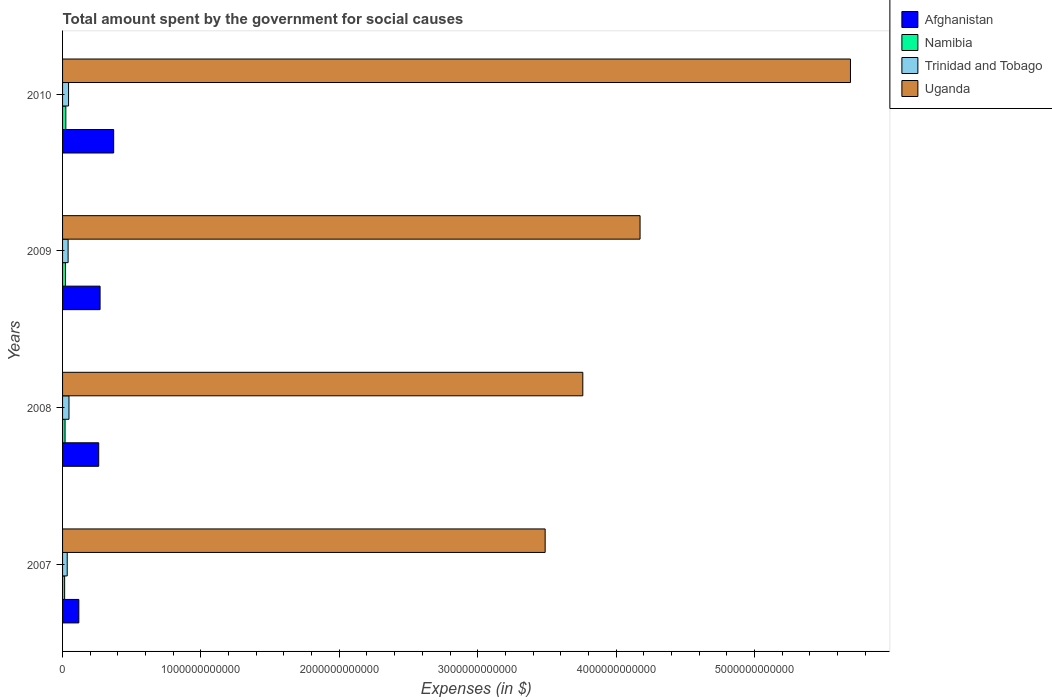Are the number of bars per tick equal to the number of legend labels?
Offer a very short reply. Yes. Are the number of bars on each tick of the Y-axis equal?
Your answer should be very brief. Yes. How many bars are there on the 4th tick from the bottom?
Offer a very short reply. 4. What is the label of the 4th group of bars from the top?
Your answer should be very brief. 2007. What is the amount spent for social causes by the government in Afghanistan in 2007?
Your answer should be compact. 1.18e+11. Across all years, what is the maximum amount spent for social causes by the government in Uganda?
Offer a terse response. 5.69e+12. Across all years, what is the minimum amount spent for social causes by the government in Uganda?
Ensure brevity in your answer.  3.49e+12. In which year was the amount spent for social causes by the government in Trinidad and Tobago maximum?
Keep it short and to the point. 2008. In which year was the amount spent for social causes by the government in Uganda minimum?
Offer a terse response. 2007. What is the total amount spent for social causes by the government in Uganda in the graph?
Offer a very short reply. 1.71e+13. What is the difference between the amount spent for social causes by the government in Trinidad and Tobago in 2008 and that in 2010?
Offer a terse response. 2.97e+09. What is the difference between the amount spent for social causes by the government in Trinidad and Tobago in 2009 and the amount spent for social causes by the government in Afghanistan in 2007?
Provide a succinct answer. -7.76e+1. What is the average amount spent for social causes by the government in Trinidad and Tobago per year?
Provide a succinct answer. 4.08e+1. In the year 2010, what is the difference between the amount spent for social causes by the government in Namibia and amount spent for social causes by the government in Trinidad and Tobago?
Offer a terse response. -1.98e+1. In how many years, is the amount spent for social causes by the government in Trinidad and Tobago greater than 2400000000000 $?
Your answer should be very brief. 0. What is the ratio of the amount spent for social causes by the government in Namibia in 2007 to that in 2008?
Your answer should be very brief. 0.83. Is the difference between the amount spent for social causes by the government in Namibia in 2007 and 2008 greater than the difference between the amount spent for social causes by the government in Trinidad and Tobago in 2007 and 2008?
Make the answer very short. Yes. What is the difference between the highest and the second highest amount spent for social causes by the government in Namibia?
Offer a terse response. 2.68e+09. What is the difference between the highest and the lowest amount spent for social causes by the government in Trinidad and Tobago?
Your answer should be very brief. 1.28e+1. Is it the case that in every year, the sum of the amount spent for social causes by the government in Trinidad and Tobago and amount spent for social causes by the government in Namibia is greater than the sum of amount spent for social causes by the government in Afghanistan and amount spent for social causes by the government in Uganda?
Offer a very short reply. No. What does the 4th bar from the top in 2008 represents?
Your answer should be very brief. Afghanistan. What does the 1st bar from the bottom in 2008 represents?
Make the answer very short. Afghanistan. Is it the case that in every year, the sum of the amount spent for social causes by the government in Trinidad and Tobago and amount spent for social causes by the government in Namibia is greater than the amount spent for social causes by the government in Afghanistan?
Provide a short and direct response. No. How many bars are there?
Offer a terse response. 16. How many years are there in the graph?
Make the answer very short. 4. What is the difference between two consecutive major ticks on the X-axis?
Offer a terse response. 1.00e+12. Are the values on the major ticks of X-axis written in scientific E-notation?
Your answer should be very brief. No. Does the graph contain grids?
Your answer should be very brief. No. What is the title of the graph?
Your response must be concise. Total amount spent by the government for social causes. What is the label or title of the X-axis?
Offer a terse response. Expenses (in $). What is the Expenses (in $) of Afghanistan in 2007?
Provide a succinct answer. 1.18e+11. What is the Expenses (in $) in Namibia in 2007?
Give a very brief answer. 1.49e+1. What is the Expenses (in $) in Trinidad and Tobago in 2007?
Your answer should be compact. 3.36e+1. What is the Expenses (in $) of Uganda in 2007?
Your answer should be very brief. 3.49e+12. What is the Expenses (in $) of Afghanistan in 2008?
Ensure brevity in your answer.  2.61e+11. What is the Expenses (in $) in Namibia in 2008?
Offer a very short reply. 1.80e+1. What is the Expenses (in $) of Trinidad and Tobago in 2008?
Your response must be concise. 4.63e+1. What is the Expenses (in $) in Uganda in 2008?
Offer a very short reply. 3.76e+12. What is the Expenses (in $) in Afghanistan in 2009?
Your response must be concise. 2.71e+11. What is the Expenses (in $) of Namibia in 2009?
Provide a succinct answer. 2.09e+1. What is the Expenses (in $) in Trinidad and Tobago in 2009?
Provide a short and direct response. 4.00e+1. What is the Expenses (in $) of Uganda in 2009?
Make the answer very short. 4.17e+12. What is the Expenses (in $) in Afghanistan in 2010?
Offer a terse response. 3.69e+11. What is the Expenses (in $) of Namibia in 2010?
Your response must be concise. 2.36e+1. What is the Expenses (in $) of Trinidad and Tobago in 2010?
Provide a short and direct response. 4.34e+1. What is the Expenses (in $) in Uganda in 2010?
Make the answer very short. 5.69e+12. Across all years, what is the maximum Expenses (in $) of Afghanistan?
Your answer should be very brief. 3.69e+11. Across all years, what is the maximum Expenses (in $) in Namibia?
Make the answer very short. 2.36e+1. Across all years, what is the maximum Expenses (in $) of Trinidad and Tobago?
Keep it short and to the point. 4.63e+1. Across all years, what is the maximum Expenses (in $) in Uganda?
Make the answer very short. 5.69e+12. Across all years, what is the minimum Expenses (in $) of Afghanistan?
Make the answer very short. 1.18e+11. Across all years, what is the minimum Expenses (in $) in Namibia?
Give a very brief answer. 1.49e+1. Across all years, what is the minimum Expenses (in $) in Trinidad and Tobago?
Offer a very short reply. 3.36e+1. Across all years, what is the minimum Expenses (in $) in Uganda?
Keep it short and to the point. 3.49e+12. What is the total Expenses (in $) in Afghanistan in the graph?
Provide a succinct answer. 1.02e+12. What is the total Expenses (in $) in Namibia in the graph?
Your response must be concise. 7.75e+1. What is the total Expenses (in $) in Trinidad and Tobago in the graph?
Your response must be concise. 1.63e+11. What is the total Expenses (in $) in Uganda in the graph?
Your answer should be compact. 1.71e+13. What is the difference between the Expenses (in $) of Afghanistan in 2007 and that in 2008?
Your answer should be compact. -1.44e+11. What is the difference between the Expenses (in $) of Namibia in 2007 and that in 2008?
Your answer should be compact. -3.08e+09. What is the difference between the Expenses (in $) of Trinidad and Tobago in 2007 and that in 2008?
Your answer should be very brief. -1.28e+1. What is the difference between the Expenses (in $) of Uganda in 2007 and that in 2008?
Your answer should be compact. -2.72e+11. What is the difference between the Expenses (in $) of Afghanistan in 2007 and that in 2009?
Ensure brevity in your answer.  -1.53e+11. What is the difference between the Expenses (in $) in Namibia in 2007 and that in 2009?
Offer a terse response. -5.99e+09. What is the difference between the Expenses (in $) of Trinidad and Tobago in 2007 and that in 2009?
Your answer should be very brief. -6.47e+09. What is the difference between the Expenses (in $) in Uganda in 2007 and that in 2009?
Provide a short and direct response. -6.86e+11. What is the difference between the Expenses (in $) in Afghanistan in 2007 and that in 2010?
Make the answer very short. -2.52e+11. What is the difference between the Expenses (in $) of Namibia in 2007 and that in 2010?
Your answer should be compact. -8.67e+09. What is the difference between the Expenses (in $) in Trinidad and Tobago in 2007 and that in 2010?
Keep it short and to the point. -9.80e+09. What is the difference between the Expenses (in $) of Uganda in 2007 and that in 2010?
Provide a short and direct response. -2.21e+12. What is the difference between the Expenses (in $) in Afghanistan in 2008 and that in 2009?
Your answer should be compact. -9.86e+09. What is the difference between the Expenses (in $) of Namibia in 2008 and that in 2009?
Ensure brevity in your answer.  -2.91e+09. What is the difference between the Expenses (in $) of Trinidad and Tobago in 2008 and that in 2009?
Your answer should be compact. 6.29e+09. What is the difference between the Expenses (in $) of Uganda in 2008 and that in 2009?
Ensure brevity in your answer.  -4.14e+11. What is the difference between the Expenses (in $) of Afghanistan in 2008 and that in 2010?
Offer a terse response. -1.08e+11. What is the difference between the Expenses (in $) in Namibia in 2008 and that in 2010?
Provide a succinct answer. -5.59e+09. What is the difference between the Expenses (in $) in Trinidad and Tobago in 2008 and that in 2010?
Ensure brevity in your answer.  2.97e+09. What is the difference between the Expenses (in $) of Uganda in 2008 and that in 2010?
Provide a succinct answer. -1.93e+12. What is the difference between the Expenses (in $) of Afghanistan in 2009 and that in 2010?
Make the answer very short. -9.83e+1. What is the difference between the Expenses (in $) in Namibia in 2009 and that in 2010?
Offer a very short reply. -2.68e+09. What is the difference between the Expenses (in $) of Trinidad and Tobago in 2009 and that in 2010?
Ensure brevity in your answer.  -3.33e+09. What is the difference between the Expenses (in $) in Uganda in 2009 and that in 2010?
Offer a very short reply. -1.52e+12. What is the difference between the Expenses (in $) of Afghanistan in 2007 and the Expenses (in $) of Namibia in 2008?
Your answer should be very brief. 9.97e+1. What is the difference between the Expenses (in $) of Afghanistan in 2007 and the Expenses (in $) of Trinidad and Tobago in 2008?
Give a very brief answer. 7.13e+1. What is the difference between the Expenses (in $) in Afghanistan in 2007 and the Expenses (in $) in Uganda in 2008?
Offer a very short reply. -3.64e+12. What is the difference between the Expenses (in $) of Namibia in 2007 and the Expenses (in $) of Trinidad and Tobago in 2008?
Offer a very short reply. -3.14e+1. What is the difference between the Expenses (in $) of Namibia in 2007 and the Expenses (in $) of Uganda in 2008?
Keep it short and to the point. -3.74e+12. What is the difference between the Expenses (in $) of Trinidad and Tobago in 2007 and the Expenses (in $) of Uganda in 2008?
Your answer should be very brief. -3.73e+12. What is the difference between the Expenses (in $) of Afghanistan in 2007 and the Expenses (in $) of Namibia in 2009?
Your response must be concise. 9.68e+1. What is the difference between the Expenses (in $) in Afghanistan in 2007 and the Expenses (in $) in Trinidad and Tobago in 2009?
Ensure brevity in your answer.  7.76e+1. What is the difference between the Expenses (in $) in Afghanistan in 2007 and the Expenses (in $) in Uganda in 2009?
Your answer should be very brief. -4.06e+12. What is the difference between the Expenses (in $) in Namibia in 2007 and the Expenses (in $) in Trinidad and Tobago in 2009?
Make the answer very short. -2.51e+1. What is the difference between the Expenses (in $) of Namibia in 2007 and the Expenses (in $) of Uganda in 2009?
Your response must be concise. -4.16e+12. What is the difference between the Expenses (in $) of Trinidad and Tobago in 2007 and the Expenses (in $) of Uganda in 2009?
Make the answer very short. -4.14e+12. What is the difference between the Expenses (in $) of Afghanistan in 2007 and the Expenses (in $) of Namibia in 2010?
Offer a very short reply. 9.41e+1. What is the difference between the Expenses (in $) in Afghanistan in 2007 and the Expenses (in $) in Trinidad and Tobago in 2010?
Offer a terse response. 7.43e+1. What is the difference between the Expenses (in $) of Afghanistan in 2007 and the Expenses (in $) of Uganda in 2010?
Offer a very short reply. -5.58e+12. What is the difference between the Expenses (in $) of Namibia in 2007 and the Expenses (in $) of Trinidad and Tobago in 2010?
Your answer should be compact. -2.84e+1. What is the difference between the Expenses (in $) in Namibia in 2007 and the Expenses (in $) in Uganda in 2010?
Keep it short and to the point. -5.68e+12. What is the difference between the Expenses (in $) in Trinidad and Tobago in 2007 and the Expenses (in $) in Uganda in 2010?
Offer a terse response. -5.66e+12. What is the difference between the Expenses (in $) in Afghanistan in 2008 and the Expenses (in $) in Namibia in 2009?
Your answer should be very brief. 2.40e+11. What is the difference between the Expenses (in $) in Afghanistan in 2008 and the Expenses (in $) in Trinidad and Tobago in 2009?
Your response must be concise. 2.21e+11. What is the difference between the Expenses (in $) in Afghanistan in 2008 and the Expenses (in $) in Uganda in 2009?
Give a very brief answer. -3.91e+12. What is the difference between the Expenses (in $) in Namibia in 2008 and the Expenses (in $) in Trinidad and Tobago in 2009?
Make the answer very short. -2.20e+1. What is the difference between the Expenses (in $) of Namibia in 2008 and the Expenses (in $) of Uganda in 2009?
Offer a terse response. -4.16e+12. What is the difference between the Expenses (in $) of Trinidad and Tobago in 2008 and the Expenses (in $) of Uganda in 2009?
Provide a short and direct response. -4.13e+12. What is the difference between the Expenses (in $) in Afghanistan in 2008 and the Expenses (in $) in Namibia in 2010?
Offer a very short reply. 2.38e+11. What is the difference between the Expenses (in $) in Afghanistan in 2008 and the Expenses (in $) in Trinidad and Tobago in 2010?
Offer a terse response. 2.18e+11. What is the difference between the Expenses (in $) of Afghanistan in 2008 and the Expenses (in $) of Uganda in 2010?
Your response must be concise. -5.43e+12. What is the difference between the Expenses (in $) of Namibia in 2008 and the Expenses (in $) of Trinidad and Tobago in 2010?
Provide a succinct answer. -2.53e+1. What is the difference between the Expenses (in $) in Namibia in 2008 and the Expenses (in $) in Uganda in 2010?
Provide a short and direct response. -5.68e+12. What is the difference between the Expenses (in $) of Trinidad and Tobago in 2008 and the Expenses (in $) of Uganda in 2010?
Provide a short and direct response. -5.65e+12. What is the difference between the Expenses (in $) in Afghanistan in 2009 and the Expenses (in $) in Namibia in 2010?
Ensure brevity in your answer.  2.47e+11. What is the difference between the Expenses (in $) in Afghanistan in 2009 and the Expenses (in $) in Trinidad and Tobago in 2010?
Provide a short and direct response. 2.28e+11. What is the difference between the Expenses (in $) in Afghanistan in 2009 and the Expenses (in $) in Uganda in 2010?
Offer a terse response. -5.42e+12. What is the difference between the Expenses (in $) of Namibia in 2009 and the Expenses (in $) of Trinidad and Tobago in 2010?
Offer a terse response. -2.24e+1. What is the difference between the Expenses (in $) in Namibia in 2009 and the Expenses (in $) in Uganda in 2010?
Provide a succinct answer. -5.67e+12. What is the difference between the Expenses (in $) of Trinidad and Tobago in 2009 and the Expenses (in $) of Uganda in 2010?
Provide a short and direct response. -5.65e+12. What is the average Expenses (in $) of Afghanistan per year?
Make the answer very short. 2.55e+11. What is the average Expenses (in $) of Namibia per year?
Make the answer very short. 1.94e+1. What is the average Expenses (in $) in Trinidad and Tobago per year?
Your response must be concise. 4.08e+1. What is the average Expenses (in $) in Uganda per year?
Provide a succinct answer. 4.28e+12. In the year 2007, what is the difference between the Expenses (in $) in Afghanistan and Expenses (in $) in Namibia?
Keep it short and to the point. 1.03e+11. In the year 2007, what is the difference between the Expenses (in $) in Afghanistan and Expenses (in $) in Trinidad and Tobago?
Your response must be concise. 8.41e+1. In the year 2007, what is the difference between the Expenses (in $) of Afghanistan and Expenses (in $) of Uganda?
Keep it short and to the point. -3.37e+12. In the year 2007, what is the difference between the Expenses (in $) of Namibia and Expenses (in $) of Trinidad and Tobago?
Give a very brief answer. -1.86e+1. In the year 2007, what is the difference between the Expenses (in $) of Namibia and Expenses (in $) of Uganda?
Your answer should be very brief. -3.47e+12. In the year 2007, what is the difference between the Expenses (in $) in Trinidad and Tobago and Expenses (in $) in Uganda?
Provide a short and direct response. -3.45e+12. In the year 2008, what is the difference between the Expenses (in $) of Afghanistan and Expenses (in $) of Namibia?
Offer a terse response. 2.43e+11. In the year 2008, what is the difference between the Expenses (in $) of Afghanistan and Expenses (in $) of Trinidad and Tobago?
Offer a very short reply. 2.15e+11. In the year 2008, what is the difference between the Expenses (in $) of Afghanistan and Expenses (in $) of Uganda?
Provide a succinct answer. -3.50e+12. In the year 2008, what is the difference between the Expenses (in $) of Namibia and Expenses (in $) of Trinidad and Tobago?
Offer a very short reply. -2.83e+1. In the year 2008, what is the difference between the Expenses (in $) in Namibia and Expenses (in $) in Uganda?
Your answer should be compact. -3.74e+12. In the year 2008, what is the difference between the Expenses (in $) of Trinidad and Tobago and Expenses (in $) of Uganda?
Give a very brief answer. -3.71e+12. In the year 2009, what is the difference between the Expenses (in $) in Afghanistan and Expenses (in $) in Namibia?
Your answer should be compact. 2.50e+11. In the year 2009, what is the difference between the Expenses (in $) in Afghanistan and Expenses (in $) in Trinidad and Tobago?
Provide a succinct answer. 2.31e+11. In the year 2009, what is the difference between the Expenses (in $) in Afghanistan and Expenses (in $) in Uganda?
Your answer should be very brief. -3.90e+12. In the year 2009, what is the difference between the Expenses (in $) of Namibia and Expenses (in $) of Trinidad and Tobago?
Keep it short and to the point. -1.91e+1. In the year 2009, what is the difference between the Expenses (in $) of Namibia and Expenses (in $) of Uganda?
Offer a very short reply. -4.15e+12. In the year 2009, what is the difference between the Expenses (in $) in Trinidad and Tobago and Expenses (in $) in Uganda?
Give a very brief answer. -4.13e+12. In the year 2010, what is the difference between the Expenses (in $) in Afghanistan and Expenses (in $) in Namibia?
Keep it short and to the point. 3.46e+11. In the year 2010, what is the difference between the Expenses (in $) of Afghanistan and Expenses (in $) of Trinidad and Tobago?
Keep it short and to the point. 3.26e+11. In the year 2010, what is the difference between the Expenses (in $) of Afghanistan and Expenses (in $) of Uganda?
Make the answer very short. -5.32e+12. In the year 2010, what is the difference between the Expenses (in $) of Namibia and Expenses (in $) of Trinidad and Tobago?
Your response must be concise. -1.98e+1. In the year 2010, what is the difference between the Expenses (in $) in Namibia and Expenses (in $) in Uganda?
Give a very brief answer. -5.67e+12. In the year 2010, what is the difference between the Expenses (in $) of Trinidad and Tobago and Expenses (in $) of Uganda?
Your response must be concise. -5.65e+12. What is the ratio of the Expenses (in $) of Afghanistan in 2007 to that in 2008?
Offer a very short reply. 0.45. What is the ratio of the Expenses (in $) of Namibia in 2007 to that in 2008?
Offer a very short reply. 0.83. What is the ratio of the Expenses (in $) of Trinidad and Tobago in 2007 to that in 2008?
Give a very brief answer. 0.72. What is the ratio of the Expenses (in $) of Uganda in 2007 to that in 2008?
Keep it short and to the point. 0.93. What is the ratio of the Expenses (in $) of Afghanistan in 2007 to that in 2009?
Give a very brief answer. 0.43. What is the ratio of the Expenses (in $) of Namibia in 2007 to that in 2009?
Ensure brevity in your answer.  0.71. What is the ratio of the Expenses (in $) in Trinidad and Tobago in 2007 to that in 2009?
Offer a terse response. 0.84. What is the ratio of the Expenses (in $) of Uganda in 2007 to that in 2009?
Your answer should be very brief. 0.84. What is the ratio of the Expenses (in $) in Afghanistan in 2007 to that in 2010?
Make the answer very short. 0.32. What is the ratio of the Expenses (in $) in Namibia in 2007 to that in 2010?
Offer a very short reply. 0.63. What is the ratio of the Expenses (in $) of Trinidad and Tobago in 2007 to that in 2010?
Provide a short and direct response. 0.77. What is the ratio of the Expenses (in $) of Uganda in 2007 to that in 2010?
Your answer should be compact. 0.61. What is the ratio of the Expenses (in $) of Afghanistan in 2008 to that in 2009?
Provide a succinct answer. 0.96. What is the ratio of the Expenses (in $) in Namibia in 2008 to that in 2009?
Give a very brief answer. 0.86. What is the ratio of the Expenses (in $) in Trinidad and Tobago in 2008 to that in 2009?
Your response must be concise. 1.16. What is the ratio of the Expenses (in $) in Uganda in 2008 to that in 2009?
Your answer should be very brief. 0.9. What is the ratio of the Expenses (in $) in Afghanistan in 2008 to that in 2010?
Offer a terse response. 0.71. What is the ratio of the Expenses (in $) in Namibia in 2008 to that in 2010?
Make the answer very short. 0.76. What is the ratio of the Expenses (in $) of Trinidad and Tobago in 2008 to that in 2010?
Give a very brief answer. 1.07. What is the ratio of the Expenses (in $) in Uganda in 2008 to that in 2010?
Provide a succinct answer. 0.66. What is the ratio of the Expenses (in $) of Afghanistan in 2009 to that in 2010?
Your answer should be very brief. 0.73. What is the ratio of the Expenses (in $) in Namibia in 2009 to that in 2010?
Give a very brief answer. 0.89. What is the ratio of the Expenses (in $) of Trinidad and Tobago in 2009 to that in 2010?
Your answer should be compact. 0.92. What is the ratio of the Expenses (in $) of Uganda in 2009 to that in 2010?
Your answer should be compact. 0.73. What is the difference between the highest and the second highest Expenses (in $) of Afghanistan?
Offer a terse response. 9.83e+1. What is the difference between the highest and the second highest Expenses (in $) in Namibia?
Your answer should be compact. 2.68e+09. What is the difference between the highest and the second highest Expenses (in $) in Trinidad and Tobago?
Ensure brevity in your answer.  2.97e+09. What is the difference between the highest and the second highest Expenses (in $) of Uganda?
Offer a very short reply. 1.52e+12. What is the difference between the highest and the lowest Expenses (in $) in Afghanistan?
Offer a very short reply. 2.52e+11. What is the difference between the highest and the lowest Expenses (in $) in Namibia?
Give a very brief answer. 8.67e+09. What is the difference between the highest and the lowest Expenses (in $) of Trinidad and Tobago?
Offer a terse response. 1.28e+1. What is the difference between the highest and the lowest Expenses (in $) of Uganda?
Keep it short and to the point. 2.21e+12. 